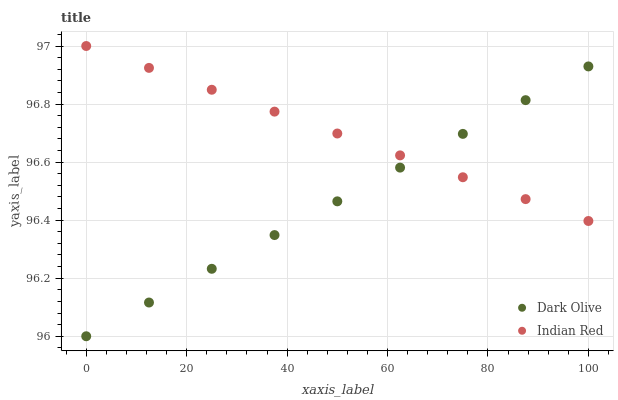Does Dark Olive have the minimum area under the curve?
Answer yes or no. Yes. Does Indian Red have the maximum area under the curve?
Answer yes or no. Yes. Does Indian Red have the minimum area under the curve?
Answer yes or no. No. Is Dark Olive the smoothest?
Answer yes or no. Yes. Is Indian Red the roughest?
Answer yes or no. Yes. Is Indian Red the smoothest?
Answer yes or no. No. Does Dark Olive have the lowest value?
Answer yes or no. Yes. Does Indian Red have the lowest value?
Answer yes or no. No. Does Indian Red have the highest value?
Answer yes or no. Yes. Does Dark Olive intersect Indian Red?
Answer yes or no. Yes. Is Dark Olive less than Indian Red?
Answer yes or no. No. Is Dark Olive greater than Indian Red?
Answer yes or no. No. 